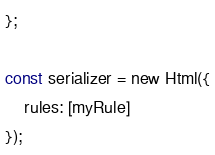<code> <loc_0><loc_0><loc_500><loc_500><_TypeScript_>};

const serializer = new Html({
    rules: [myRule]
});
</code> 